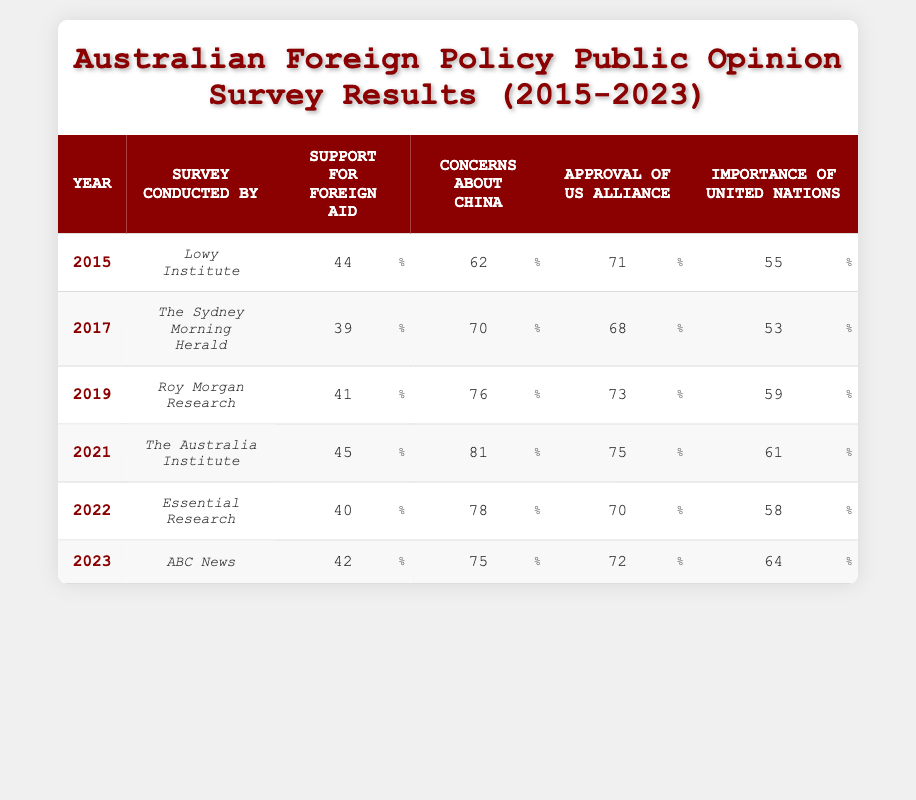What was the support for foreign aid in 2019? According to the table, the support for foreign aid in 2019, as indicated in the corresponding row, is 41.
Answer: 41 What percentage of Australians expressed concerns about China in 2021? The table shows that in 2021, the concerns about China were reported at 81%, taking the value directly from that year's entry.
Answer: 81 Which year had the highest approval for the US alliance? By examining the approval rates for the US alliance in the table, it's clear that 2019 had the highest percentage at 73%.
Answer: 73 What is the average importance of the United Nations from 2015 to 2023? To calculate the average, add the importance values: 55 + 53 + 59 + 61 + 58 + 64 = 310. Then, divide by the number of years (6) to get the average: 310 / 6 = 51.67.
Answer: 51.67 Did concerns about China decrease from 2021 to 2023? In 2021, the concerns about China were at 81%, while in 2023, they decreased to 75%. Since 75 is less than 81, the statement is true.
Answer: Yes Which survey showed the lowest support for foreign aid, and what was its percentage? The lowest support for foreign aid was in 2017, as seen in the table, with a percentage of 39%.
Answer: 39 How much did concerns about China increase from 2015 to 2022? In 2015, concerns about China were 62%, and in 2022, they were 78%. The increase can be calculated as 78 - 62 = 16%.
Answer: 16 Was the support for foreign aid lower in 2022 compared to 2017? The support for foreign aid in 2022 was 40%, while in 2017 it was 39%. Since 40 is greater than 39, the statement is false.
Answer: No Which year had the most significant change in the approval of the US alliance? Comparing the figures for the US alliance, from 2017 (68) to 2021 (75), there is a change of 7. However, from 2022 (70) to 2021 (75), there is also a change of 5. The most significant change was from 2019 to 2021, showing a 2% increase from 75 to 73.
Answer: 7 